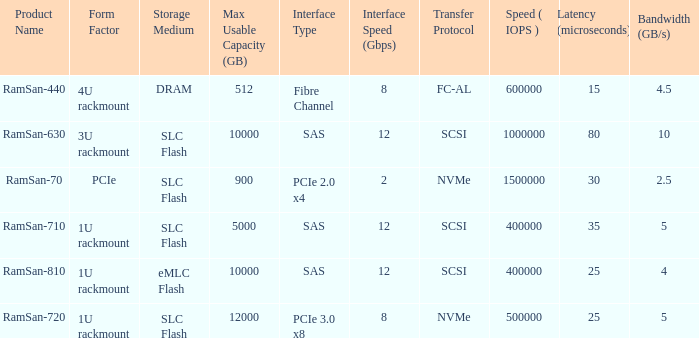I'm looking to parse the entire table for insights. Could you assist me with that? {'header': ['Product Name', 'Form Factor', 'Storage Medium', 'Max Usable Capacity (GB)', 'Interface Type', 'Interface Speed (Gbps)', 'Transfer Protocol', 'Speed ( IOPS )', 'Latency (microseconds)', 'Bandwidth (GB/s)'], 'rows': [['RamSan-440', '4U rackmount', 'DRAM', '512', 'Fibre Channel', '8', 'FC-AL', '600000', '15', '4.5'], ['RamSan-630', '3U rackmount', 'SLC Flash', '10000', 'SAS', '12', 'SCSI', '1000000', '80', '10'], ['RamSan-70', 'PCIe', 'SLC Flash', '900', 'PCIe 2.0 x4', '2', 'NVMe', '1500000', '30', '2.5'], ['RamSan-710', '1U rackmount', 'SLC Flash', '5000', 'SAS', '12', 'SCSI', '400000', '35', '5'], ['RamSan-810', '1U rackmount', 'eMLC Flash', '10000', 'SAS', '12', 'SCSI', '400000', '25', '4'], ['RamSan-720', '1U rackmount', 'SLC Flash', '12000', 'PCIe 3.0 x8', '8', 'NVMe', '500000', '25', '5']]} What is the ramsan-810 transfer delay? 1.0. 